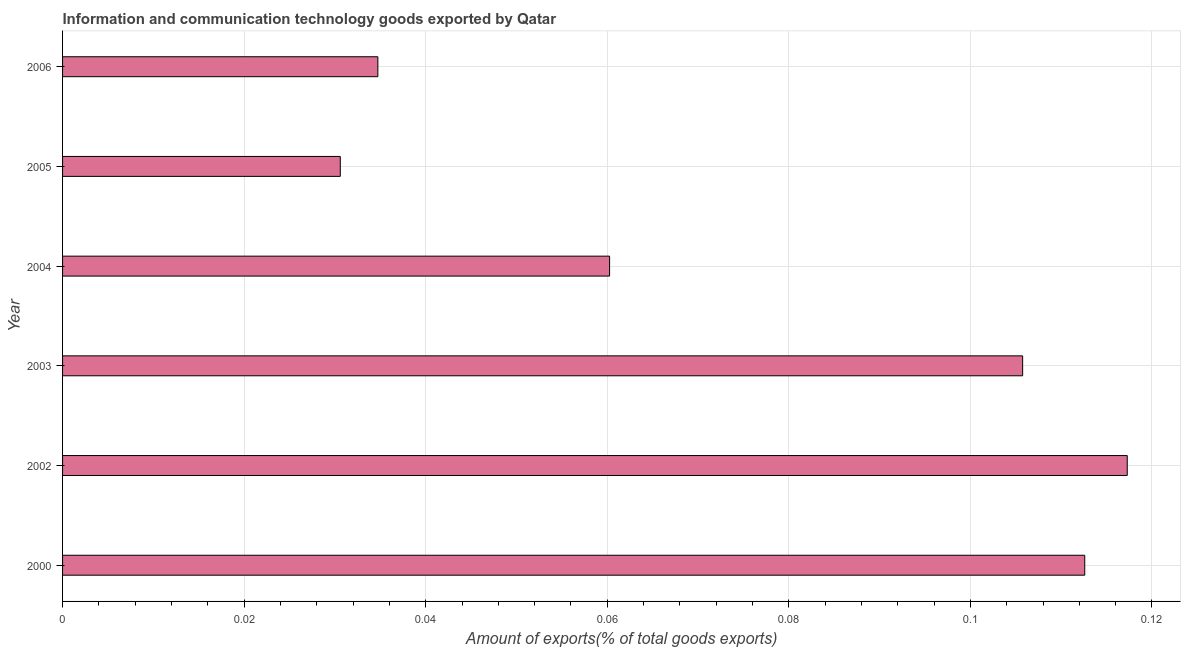Does the graph contain any zero values?
Provide a short and direct response. No. What is the title of the graph?
Your response must be concise. Information and communication technology goods exported by Qatar. What is the label or title of the X-axis?
Provide a succinct answer. Amount of exports(% of total goods exports). What is the label or title of the Y-axis?
Your answer should be compact. Year. What is the amount of ict goods exports in 2002?
Keep it short and to the point. 0.12. Across all years, what is the maximum amount of ict goods exports?
Your answer should be very brief. 0.12. Across all years, what is the minimum amount of ict goods exports?
Offer a very short reply. 0.03. In which year was the amount of ict goods exports maximum?
Ensure brevity in your answer.  2002. What is the sum of the amount of ict goods exports?
Your response must be concise. 0.46. What is the difference between the amount of ict goods exports in 2002 and 2003?
Your answer should be compact. 0.01. What is the average amount of ict goods exports per year?
Give a very brief answer. 0.08. What is the median amount of ict goods exports?
Ensure brevity in your answer.  0.08. What is the ratio of the amount of ict goods exports in 2002 to that in 2004?
Ensure brevity in your answer.  1.95. Is the difference between the amount of ict goods exports in 2000 and 2003 greater than the difference between any two years?
Make the answer very short. No. What is the difference between the highest and the second highest amount of ict goods exports?
Give a very brief answer. 0.01. Is the sum of the amount of ict goods exports in 2003 and 2004 greater than the maximum amount of ict goods exports across all years?
Provide a succinct answer. Yes. What is the difference between the highest and the lowest amount of ict goods exports?
Offer a terse response. 0.09. How many bars are there?
Make the answer very short. 6. Are all the bars in the graph horizontal?
Your answer should be very brief. Yes. How many years are there in the graph?
Your answer should be compact. 6. Are the values on the major ticks of X-axis written in scientific E-notation?
Make the answer very short. No. What is the Amount of exports(% of total goods exports) of 2000?
Provide a short and direct response. 0.11. What is the Amount of exports(% of total goods exports) in 2002?
Offer a very short reply. 0.12. What is the Amount of exports(% of total goods exports) of 2003?
Keep it short and to the point. 0.11. What is the Amount of exports(% of total goods exports) in 2004?
Provide a succinct answer. 0.06. What is the Amount of exports(% of total goods exports) in 2005?
Your response must be concise. 0.03. What is the Amount of exports(% of total goods exports) in 2006?
Make the answer very short. 0.03. What is the difference between the Amount of exports(% of total goods exports) in 2000 and 2002?
Your answer should be very brief. -0. What is the difference between the Amount of exports(% of total goods exports) in 2000 and 2003?
Ensure brevity in your answer.  0.01. What is the difference between the Amount of exports(% of total goods exports) in 2000 and 2004?
Offer a very short reply. 0.05. What is the difference between the Amount of exports(% of total goods exports) in 2000 and 2005?
Your answer should be very brief. 0.08. What is the difference between the Amount of exports(% of total goods exports) in 2000 and 2006?
Make the answer very short. 0.08. What is the difference between the Amount of exports(% of total goods exports) in 2002 and 2003?
Keep it short and to the point. 0.01. What is the difference between the Amount of exports(% of total goods exports) in 2002 and 2004?
Provide a succinct answer. 0.06. What is the difference between the Amount of exports(% of total goods exports) in 2002 and 2005?
Ensure brevity in your answer.  0.09. What is the difference between the Amount of exports(% of total goods exports) in 2002 and 2006?
Ensure brevity in your answer.  0.08. What is the difference between the Amount of exports(% of total goods exports) in 2003 and 2004?
Offer a very short reply. 0.05. What is the difference between the Amount of exports(% of total goods exports) in 2003 and 2005?
Keep it short and to the point. 0.08. What is the difference between the Amount of exports(% of total goods exports) in 2003 and 2006?
Provide a succinct answer. 0.07. What is the difference between the Amount of exports(% of total goods exports) in 2004 and 2005?
Keep it short and to the point. 0.03. What is the difference between the Amount of exports(% of total goods exports) in 2004 and 2006?
Keep it short and to the point. 0.03. What is the difference between the Amount of exports(% of total goods exports) in 2005 and 2006?
Your answer should be compact. -0. What is the ratio of the Amount of exports(% of total goods exports) in 2000 to that in 2003?
Offer a very short reply. 1.06. What is the ratio of the Amount of exports(% of total goods exports) in 2000 to that in 2004?
Your response must be concise. 1.87. What is the ratio of the Amount of exports(% of total goods exports) in 2000 to that in 2005?
Your answer should be very brief. 3.68. What is the ratio of the Amount of exports(% of total goods exports) in 2000 to that in 2006?
Offer a terse response. 3.24. What is the ratio of the Amount of exports(% of total goods exports) in 2002 to that in 2003?
Offer a very short reply. 1.11. What is the ratio of the Amount of exports(% of total goods exports) in 2002 to that in 2004?
Your response must be concise. 1.95. What is the ratio of the Amount of exports(% of total goods exports) in 2002 to that in 2005?
Provide a succinct answer. 3.83. What is the ratio of the Amount of exports(% of total goods exports) in 2002 to that in 2006?
Provide a short and direct response. 3.38. What is the ratio of the Amount of exports(% of total goods exports) in 2003 to that in 2004?
Make the answer very short. 1.75. What is the ratio of the Amount of exports(% of total goods exports) in 2003 to that in 2005?
Provide a succinct answer. 3.46. What is the ratio of the Amount of exports(% of total goods exports) in 2003 to that in 2006?
Offer a terse response. 3.04. What is the ratio of the Amount of exports(% of total goods exports) in 2004 to that in 2005?
Your answer should be very brief. 1.97. What is the ratio of the Amount of exports(% of total goods exports) in 2004 to that in 2006?
Offer a terse response. 1.74. What is the ratio of the Amount of exports(% of total goods exports) in 2005 to that in 2006?
Your response must be concise. 0.88. 